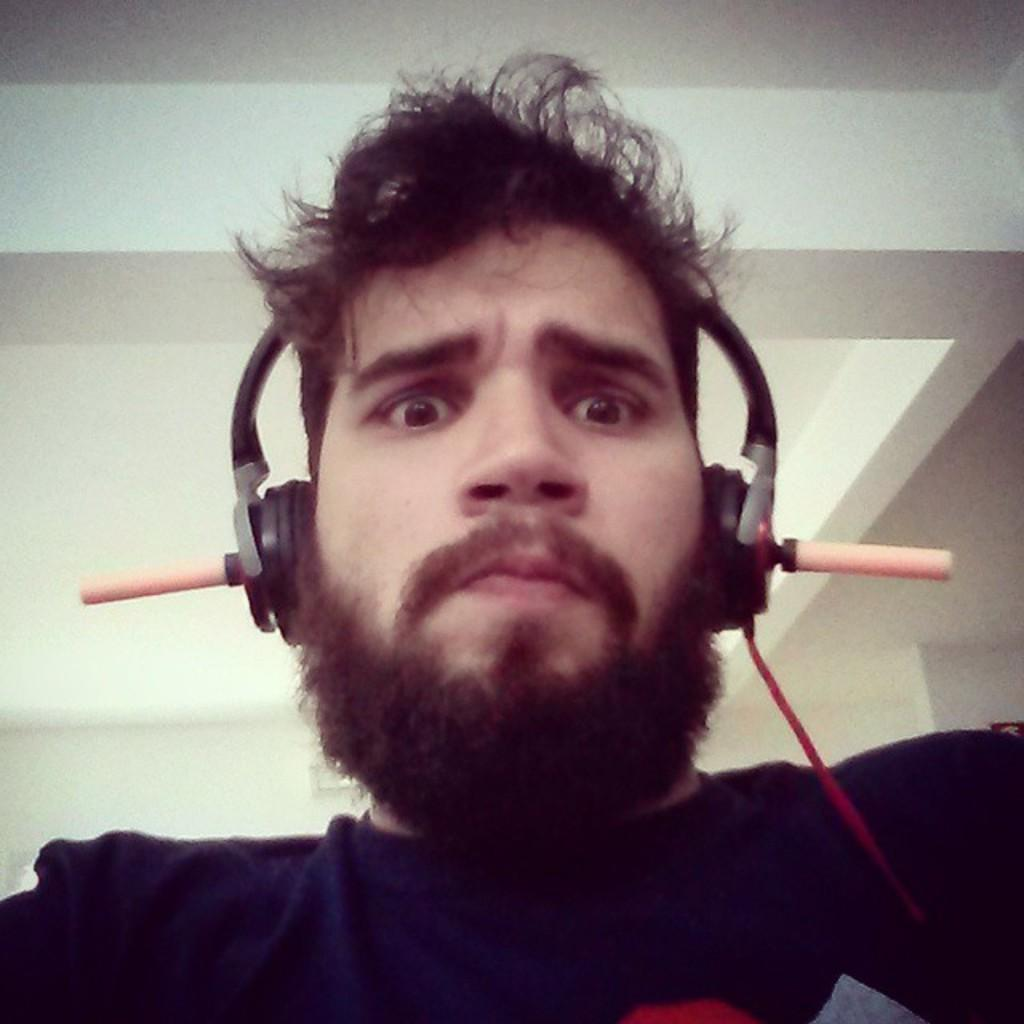Who is present in the image? There is a person in the image. What is the person wearing? The person is wearing headphones. What is the person doing in the image? The person is watching something. What can be seen in the background of the image? There is a wall and a ceiling in the background of the image. What type of ball is the person playing with in the image? There is no ball present in the image; the person is wearing headphones and watching something. 